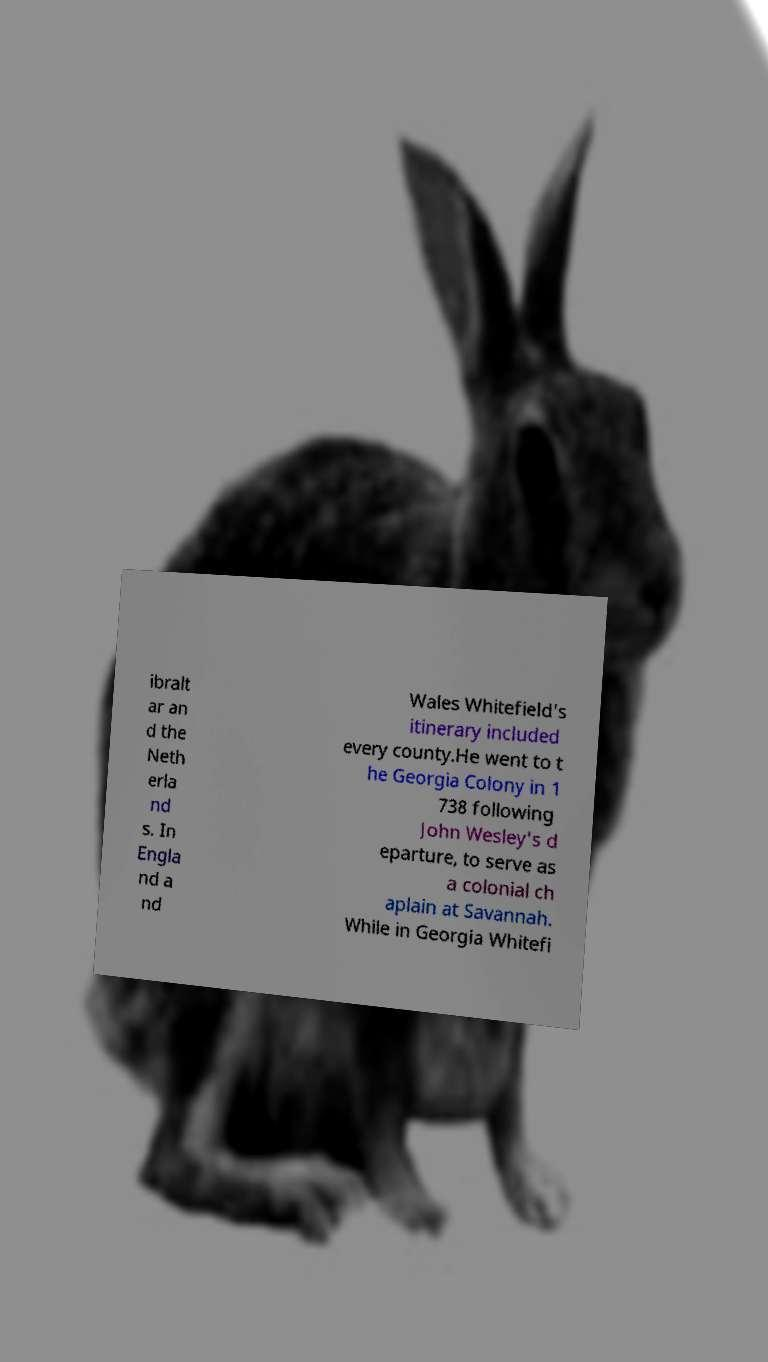I need the written content from this picture converted into text. Can you do that? ibralt ar an d the Neth erla nd s. In Engla nd a nd Wales Whitefield's itinerary included every county.He went to t he Georgia Colony in 1 738 following John Wesley's d eparture, to serve as a colonial ch aplain at Savannah. While in Georgia Whitefi 